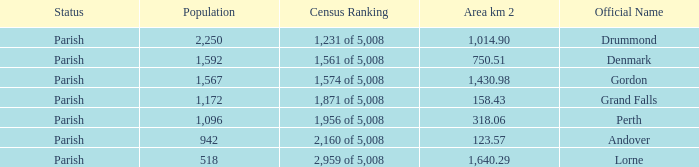Which parish has an area of 750.51? Denmark. 